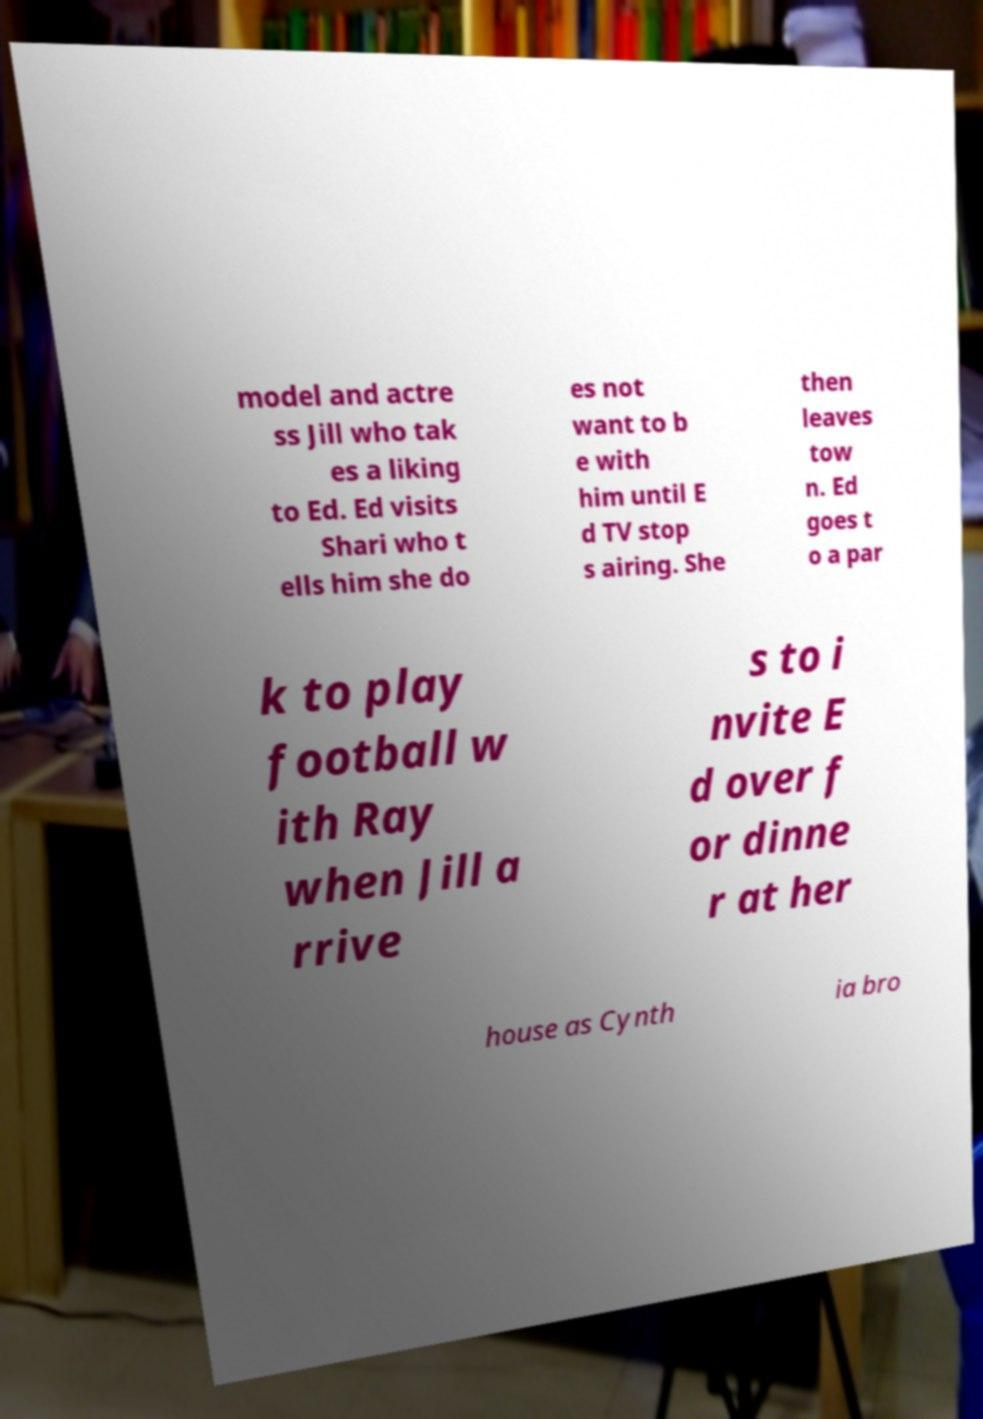Please identify and transcribe the text found in this image. model and actre ss Jill who tak es a liking to Ed. Ed visits Shari who t ells him she do es not want to b e with him until E d TV stop s airing. She then leaves tow n. Ed goes t o a par k to play football w ith Ray when Jill a rrive s to i nvite E d over f or dinne r at her house as Cynth ia bro 